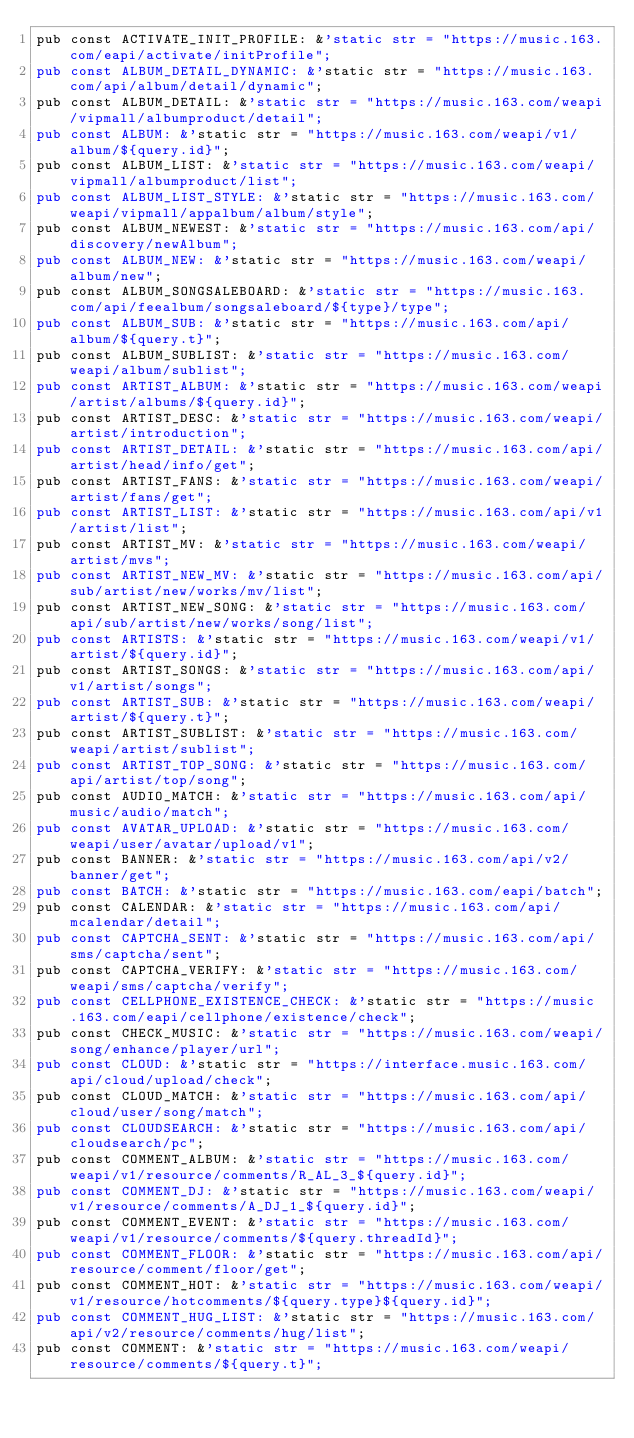Convert code to text. <code><loc_0><loc_0><loc_500><loc_500><_Rust_>pub const ACTIVATE_INIT_PROFILE: &'static str = "https://music.163.com/eapi/activate/initProfile";
pub const ALBUM_DETAIL_DYNAMIC: &'static str = "https://music.163.com/api/album/detail/dynamic";
pub const ALBUM_DETAIL: &'static str = "https://music.163.com/weapi/vipmall/albumproduct/detail";
pub const ALBUM: &'static str = "https://music.163.com/weapi/v1/album/${query.id}";
pub const ALBUM_LIST: &'static str = "https://music.163.com/weapi/vipmall/albumproduct/list";
pub const ALBUM_LIST_STYLE: &'static str = "https://music.163.com/weapi/vipmall/appalbum/album/style";
pub const ALBUM_NEWEST: &'static str = "https://music.163.com/api/discovery/newAlbum";
pub const ALBUM_NEW: &'static str = "https://music.163.com/weapi/album/new";
pub const ALBUM_SONGSALEBOARD: &'static str = "https://music.163.com/api/feealbum/songsaleboard/${type}/type";
pub const ALBUM_SUB: &'static str = "https://music.163.com/api/album/${query.t}";
pub const ALBUM_SUBLIST: &'static str = "https://music.163.com/weapi/album/sublist";
pub const ARTIST_ALBUM: &'static str = "https://music.163.com/weapi/artist/albums/${query.id}";
pub const ARTIST_DESC: &'static str = "https://music.163.com/weapi/artist/introduction";
pub const ARTIST_DETAIL: &'static str = "https://music.163.com/api/artist/head/info/get";
pub const ARTIST_FANS: &'static str = "https://music.163.com/weapi/artist/fans/get";
pub const ARTIST_LIST: &'static str = "https://music.163.com/api/v1/artist/list";
pub const ARTIST_MV: &'static str = "https://music.163.com/weapi/artist/mvs";
pub const ARTIST_NEW_MV: &'static str = "https://music.163.com/api/sub/artist/new/works/mv/list";
pub const ARTIST_NEW_SONG: &'static str = "https://music.163.com/api/sub/artist/new/works/song/list";
pub const ARTISTS: &'static str = "https://music.163.com/weapi/v1/artist/${query.id}";
pub const ARTIST_SONGS: &'static str = "https://music.163.com/api/v1/artist/songs";
pub const ARTIST_SUB: &'static str = "https://music.163.com/weapi/artist/${query.t}";
pub const ARTIST_SUBLIST: &'static str = "https://music.163.com/weapi/artist/sublist";
pub const ARTIST_TOP_SONG: &'static str = "https://music.163.com/api/artist/top/song";
pub const AUDIO_MATCH: &'static str = "https://music.163.com/api/music/audio/match";
pub const AVATAR_UPLOAD: &'static str = "https://music.163.com/weapi/user/avatar/upload/v1";
pub const BANNER: &'static str = "https://music.163.com/api/v2/banner/get";
pub const BATCH: &'static str = "https://music.163.com/eapi/batch";
pub const CALENDAR: &'static str = "https://music.163.com/api/mcalendar/detail";
pub const CAPTCHA_SENT: &'static str = "https://music.163.com/api/sms/captcha/sent";
pub const CAPTCHA_VERIFY: &'static str = "https://music.163.com/weapi/sms/captcha/verify";
pub const CELLPHONE_EXISTENCE_CHECK: &'static str = "https://music.163.com/eapi/cellphone/existence/check";
pub const CHECK_MUSIC: &'static str = "https://music.163.com/weapi/song/enhance/player/url";
pub const CLOUD: &'static str = "https://interface.music.163.com/api/cloud/upload/check";
pub const CLOUD_MATCH: &'static str = "https://music.163.com/api/cloud/user/song/match";
pub const CLOUDSEARCH: &'static str = "https://music.163.com/api/cloudsearch/pc";
pub const COMMENT_ALBUM: &'static str = "https://music.163.com/weapi/v1/resource/comments/R_AL_3_${query.id}";
pub const COMMENT_DJ: &'static str = "https://music.163.com/weapi/v1/resource/comments/A_DJ_1_${query.id}";
pub const COMMENT_EVENT: &'static str = "https://music.163.com/weapi/v1/resource/comments/${query.threadId}";
pub const COMMENT_FLOOR: &'static str = "https://music.163.com/api/resource/comment/floor/get";
pub const COMMENT_HOT: &'static str = "https://music.163.com/weapi/v1/resource/hotcomments/${query.type}${query.id}";
pub const COMMENT_HUG_LIST: &'static str = "https://music.163.com/api/v2/resource/comments/hug/list";
pub const COMMENT: &'static str = "https://music.163.com/weapi/resource/comments/${query.t}";</code> 